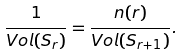<formula> <loc_0><loc_0><loc_500><loc_500>\frac { 1 } { V o l ( S _ { r } ) } = \frac { n ( r ) } { V o l ( S _ { r + 1 } ) } .</formula> 